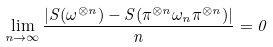Convert formula to latex. <formula><loc_0><loc_0><loc_500><loc_500>\lim _ { n \rightarrow \infty } \frac { | S ( \omega ^ { \otimes n } ) - S ( \pi ^ { \otimes n } \omega _ { n } \pi ^ { \otimes n } ) | } { n } = 0</formula> 